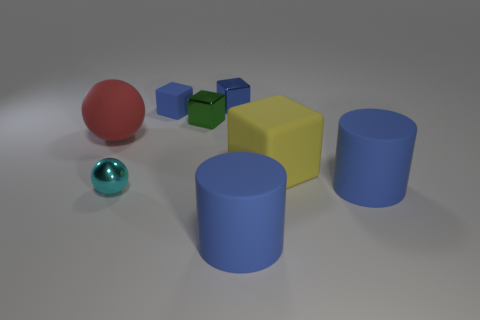There is a small shiny object that is in front of the big red ball; what color is it?
Make the answer very short. Cyan. What number of big matte cylinders have the same color as the small rubber object?
Your answer should be very brief. 2. There is a yellow object; is its size the same as the matte object that is left of the blue rubber cube?
Offer a very short reply. Yes. There is a cylinder that is in front of the metallic object that is on the left side of the small metal block that is in front of the tiny blue metal thing; what size is it?
Give a very brief answer. Large. What number of small rubber things are behind the small cyan shiny thing?
Make the answer very short. 1. What material is the cyan sphere that is to the left of the blue block to the left of the blue shiny cube?
Your response must be concise. Metal. Do the matte sphere and the green thing have the same size?
Ensure brevity in your answer.  No. What number of things are cylinders that are behind the cyan ball or large things on the right side of the big matte ball?
Your answer should be very brief. 3. Are there more small blue matte objects in front of the cyan sphere than small blocks?
Provide a short and direct response. No. How many other things are there of the same shape as the tiny green metallic object?
Provide a succinct answer. 3. 